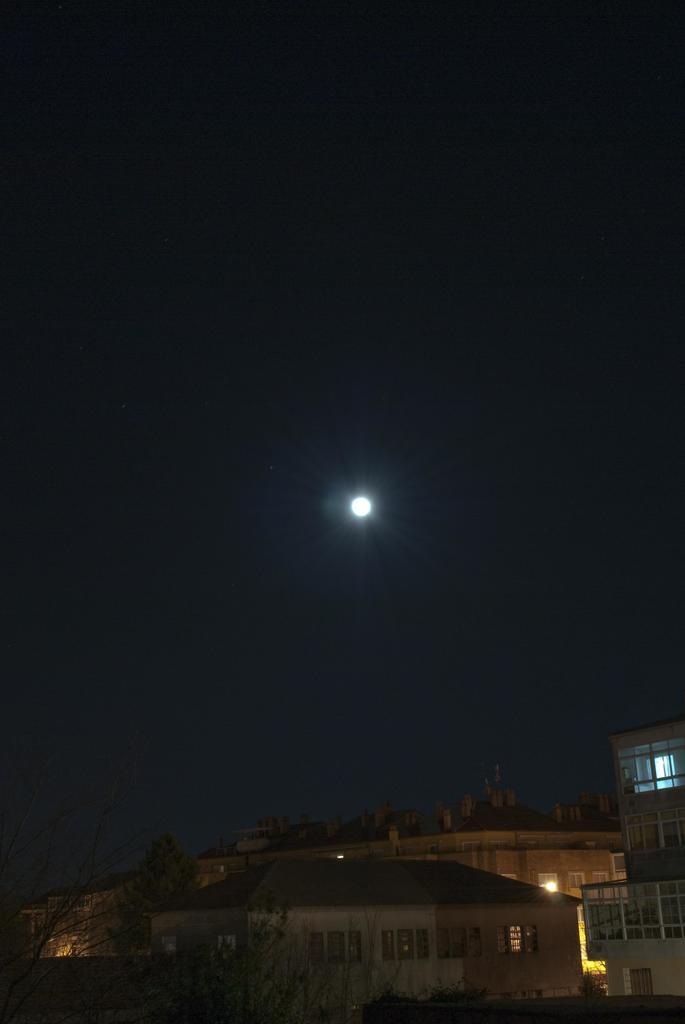What type of structures can be seen in the image? There are buildings in the image. What other natural elements are present in the image? There are trees in the image. What celestial body can be seen in the image? The moon is present in the image. What type of insect can be seen crawling on the buildings in the image? There are no insects visible in the image; only buildings, trees, and the moon can be seen. 